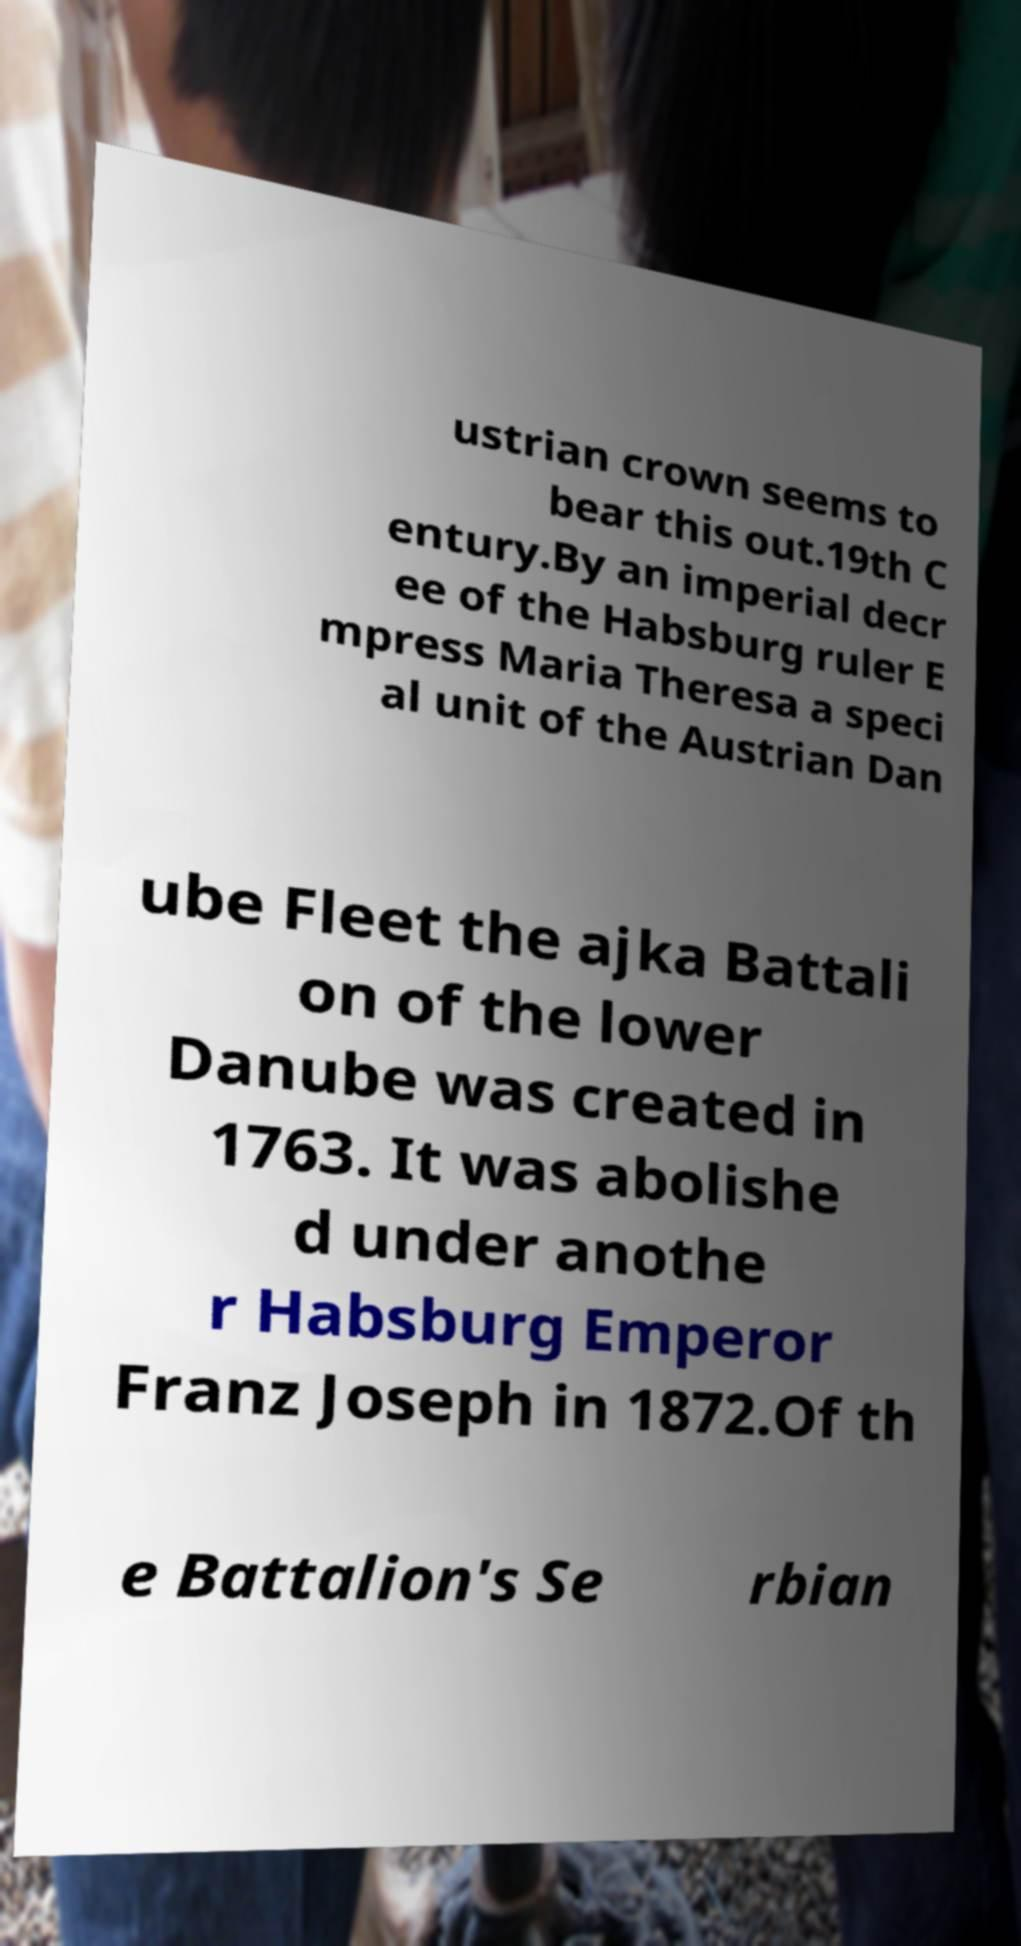Please read and relay the text visible in this image. What does it say? ustrian crown seems to bear this out.19th C entury.By an imperial decr ee of the Habsburg ruler E mpress Maria Theresa a speci al unit of the Austrian Dan ube Fleet the ajka Battali on of the lower Danube was created in 1763. It was abolishe d under anothe r Habsburg Emperor Franz Joseph in 1872.Of th e Battalion's Se rbian 